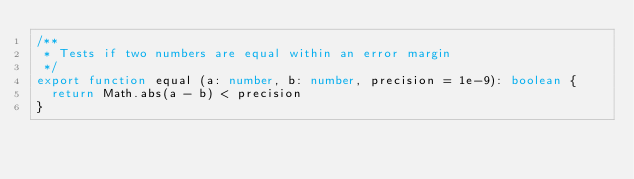<code> <loc_0><loc_0><loc_500><loc_500><_TypeScript_>/**
 * Tests if two numbers are equal within an error margin
 */
export function equal (a: number, b: number, precision = 1e-9): boolean {
  return Math.abs(a - b) < precision
}
</code> 